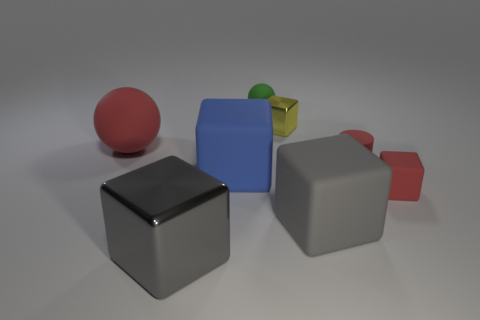Subtract all red rubber blocks. How many blocks are left? 4 Subtract 1 blocks. How many blocks are left? 4 Subtract all blue cubes. How many cubes are left? 4 Subtract all purple blocks. Subtract all brown cylinders. How many blocks are left? 5 Add 1 tiny cylinders. How many objects exist? 9 Subtract all cubes. How many objects are left? 3 Subtract all cubes. Subtract all red metal spheres. How many objects are left? 3 Add 8 yellow metal things. How many yellow metal things are left? 9 Add 2 small matte blocks. How many small matte blocks exist? 3 Subtract 0 blue cylinders. How many objects are left? 8 